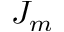<formula> <loc_0><loc_0><loc_500><loc_500>J _ { m }</formula> 